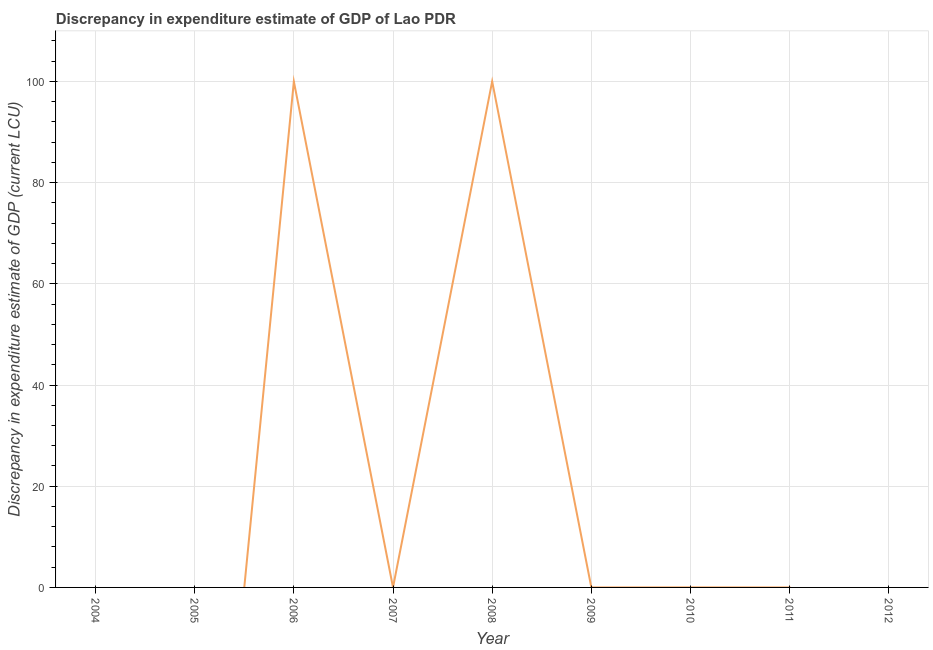What is the discrepancy in expenditure estimate of gdp in 2012?
Ensure brevity in your answer.  0. Across all years, what is the maximum discrepancy in expenditure estimate of gdp?
Offer a very short reply. 100. Across all years, what is the minimum discrepancy in expenditure estimate of gdp?
Ensure brevity in your answer.  0. What is the sum of the discrepancy in expenditure estimate of gdp?
Offer a terse response. 200.01. What is the difference between the discrepancy in expenditure estimate of gdp in 2006 and 2008?
Ensure brevity in your answer.  -0.01. What is the average discrepancy in expenditure estimate of gdp per year?
Provide a succinct answer. 22.22. What is the median discrepancy in expenditure estimate of gdp?
Your answer should be very brief. 0. What is the difference between the highest and the second highest discrepancy in expenditure estimate of gdp?
Your answer should be very brief. 0.01. In how many years, is the discrepancy in expenditure estimate of gdp greater than the average discrepancy in expenditure estimate of gdp taken over all years?
Offer a terse response. 2. Does the discrepancy in expenditure estimate of gdp monotonically increase over the years?
Ensure brevity in your answer.  No. How many years are there in the graph?
Make the answer very short. 9. Are the values on the major ticks of Y-axis written in scientific E-notation?
Give a very brief answer. No. Does the graph contain any zero values?
Ensure brevity in your answer.  Yes. What is the title of the graph?
Ensure brevity in your answer.  Discrepancy in expenditure estimate of GDP of Lao PDR. What is the label or title of the Y-axis?
Provide a succinct answer. Discrepancy in expenditure estimate of GDP (current LCU). What is the Discrepancy in expenditure estimate of GDP (current LCU) of 2005?
Keep it short and to the point. 0. What is the Discrepancy in expenditure estimate of GDP (current LCU) in 2006?
Your response must be concise. 99.99. What is the Discrepancy in expenditure estimate of GDP (current LCU) in 2007?
Make the answer very short. 0.01. What is the Discrepancy in expenditure estimate of GDP (current LCU) in 2008?
Offer a very short reply. 100. What is the Discrepancy in expenditure estimate of GDP (current LCU) of 2010?
Provide a succinct answer. 0.01. What is the Discrepancy in expenditure estimate of GDP (current LCU) in 2011?
Offer a very short reply. 0. What is the difference between the Discrepancy in expenditure estimate of GDP (current LCU) in 2006 and 2007?
Keep it short and to the point. 99.98. What is the difference between the Discrepancy in expenditure estimate of GDP (current LCU) in 2006 and 2008?
Offer a very short reply. -0.01. What is the difference between the Discrepancy in expenditure estimate of GDP (current LCU) in 2006 and 2010?
Give a very brief answer. 99.98. What is the difference between the Discrepancy in expenditure estimate of GDP (current LCU) in 2007 and 2008?
Ensure brevity in your answer.  -99.99. What is the difference between the Discrepancy in expenditure estimate of GDP (current LCU) in 2007 and 2010?
Ensure brevity in your answer.  -0. What is the difference between the Discrepancy in expenditure estimate of GDP (current LCU) in 2008 and 2010?
Your answer should be very brief. 99.99. What is the ratio of the Discrepancy in expenditure estimate of GDP (current LCU) in 2006 to that in 2007?
Your answer should be compact. 1.25e+04. What is the ratio of the Discrepancy in expenditure estimate of GDP (current LCU) in 2006 to that in 2010?
Your response must be concise. 8332.67. What is the ratio of the Discrepancy in expenditure estimate of GDP (current LCU) in 2007 to that in 2010?
Your answer should be very brief. 0.67. What is the ratio of the Discrepancy in expenditure estimate of GDP (current LCU) in 2008 to that in 2010?
Your answer should be very brief. 8333.33. 